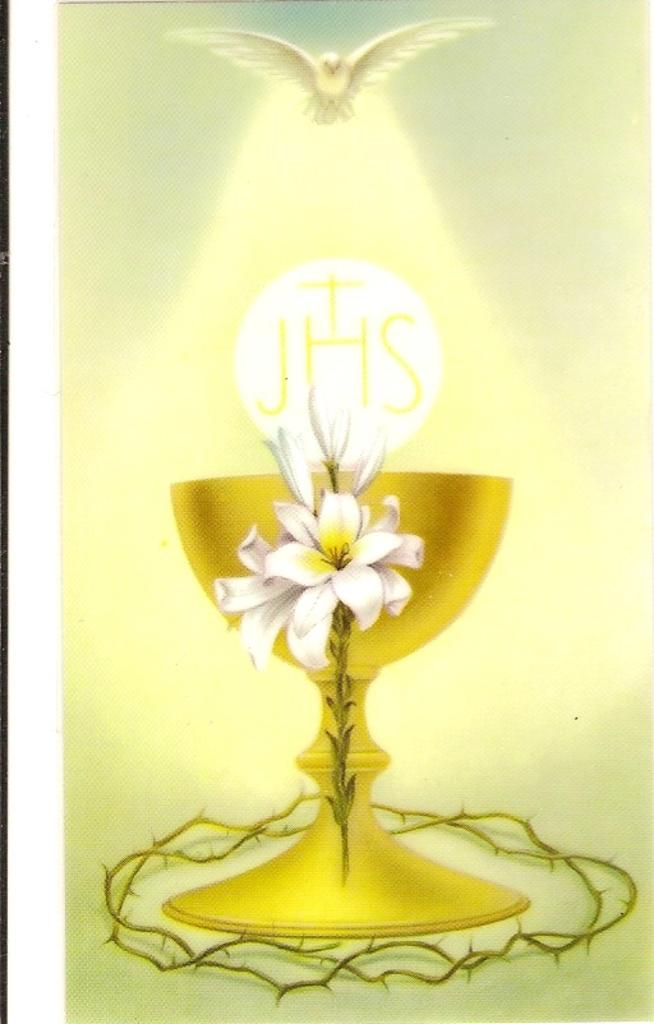What type of plants are in the image? There are flowers in the image. What is the glass used for in the image? The purpose of the glass is not specified in the image. Can you describe the bird in the image? There is a bird visible at the top of the image. What level of pickle is present in the image? There is no mention of pickle in the image, so it cannot be determined if any level of pickle is present. 